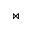<formula> <loc_0><loc_0><loc_500><loc_500>\ J o i n</formula> 